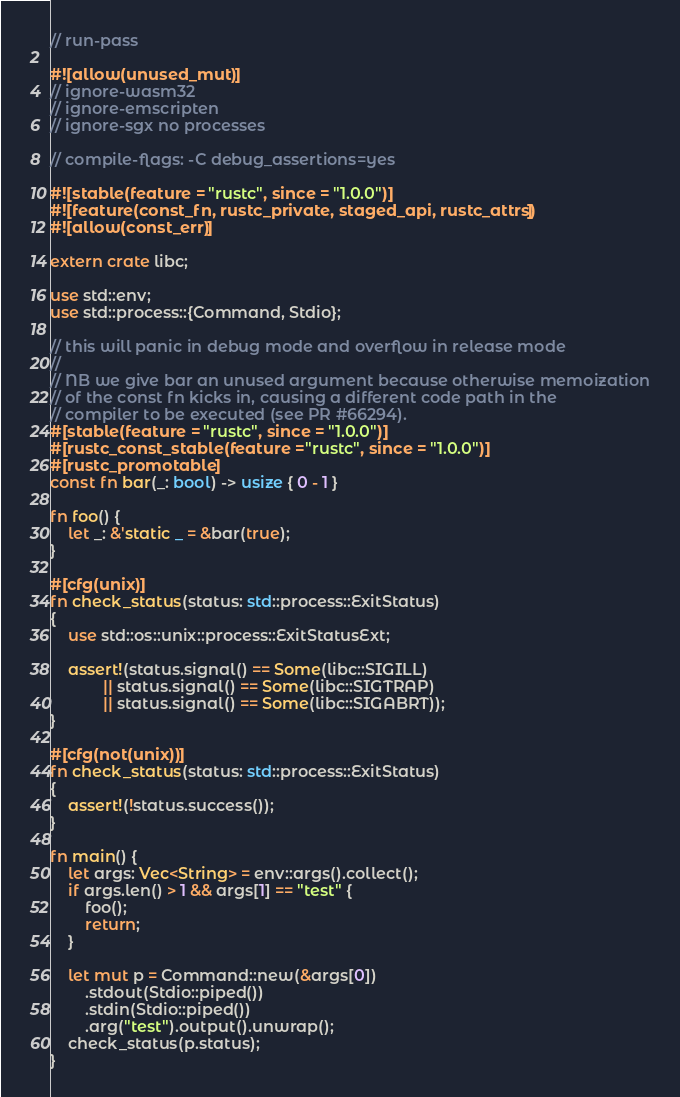<code> <loc_0><loc_0><loc_500><loc_500><_Rust_>// run-pass

#![allow(unused_mut)]
// ignore-wasm32
// ignore-emscripten
// ignore-sgx no processes

// compile-flags: -C debug_assertions=yes

#![stable(feature = "rustc", since = "1.0.0")]
#![feature(const_fn, rustc_private, staged_api, rustc_attrs)]
#![allow(const_err)]

extern crate libc;

use std::env;
use std::process::{Command, Stdio};

// this will panic in debug mode and overflow in release mode
//
// NB we give bar an unused argument because otherwise memoization
// of the const fn kicks in, causing a different code path in the
// compiler to be executed (see PR #66294).
#[stable(feature = "rustc", since = "1.0.0")]
#[rustc_const_stable(feature = "rustc", since = "1.0.0")]
#[rustc_promotable]
const fn bar(_: bool) -> usize { 0 - 1 }

fn foo() {
    let _: &'static _ = &bar(true);
}

#[cfg(unix)]
fn check_status(status: std::process::ExitStatus)
{
    use std::os::unix::process::ExitStatusExt;

    assert!(status.signal() == Some(libc::SIGILL)
            || status.signal() == Some(libc::SIGTRAP)
            || status.signal() == Some(libc::SIGABRT));
}

#[cfg(not(unix))]
fn check_status(status: std::process::ExitStatus)
{
    assert!(!status.success());
}

fn main() {
    let args: Vec<String> = env::args().collect();
    if args.len() > 1 && args[1] == "test" {
        foo();
        return;
    }

    let mut p = Command::new(&args[0])
        .stdout(Stdio::piped())
        .stdin(Stdio::piped())
        .arg("test").output().unwrap();
    check_status(p.status);
}
</code> 